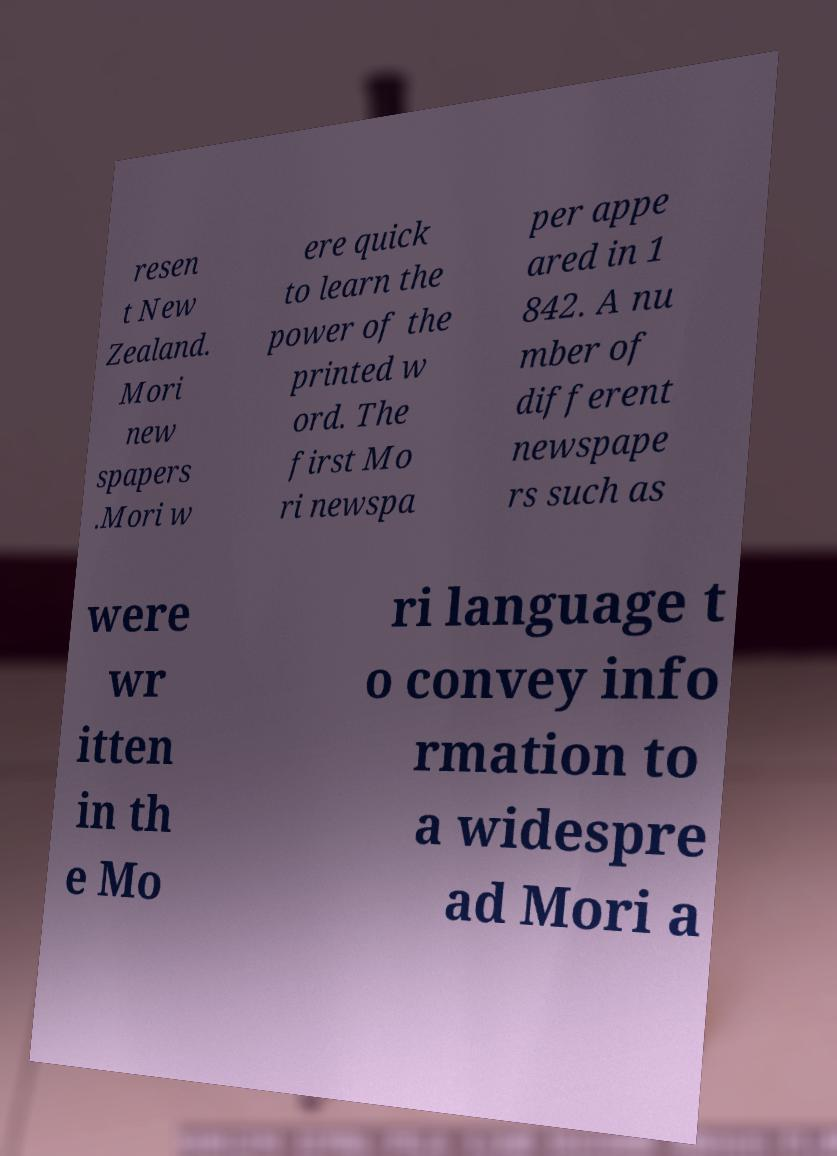Please read and relay the text visible in this image. What does it say? resen t New Zealand. Mori new spapers .Mori w ere quick to learn the power of the printed w ord. The first Mo ri newspa per appe ared in 1 842. A nu mber of different newspape rs such as were wr itten in th e Mo ri language t o convey info rmation to a widespre ad Mori a 